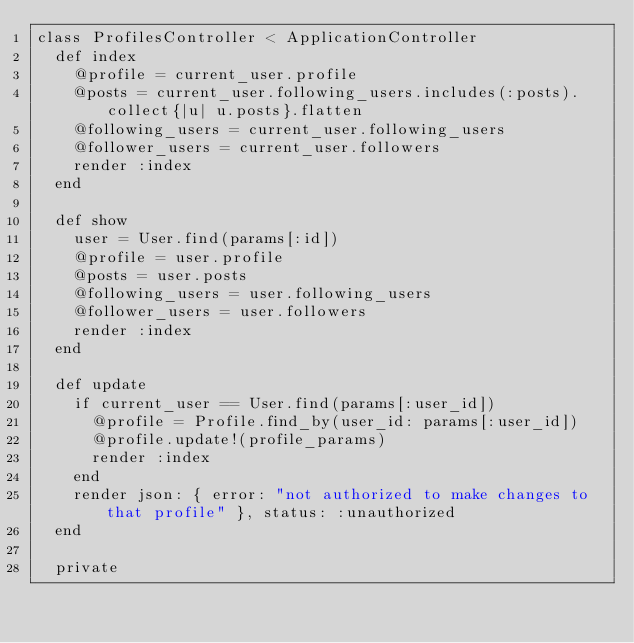<code> <loc_0><loc_0><loc_500><loc_500><_Ruby_>class ProfilesController < ApplicationController
  def index
    @profile = current_user.profile
    @posts = current_user.following_users.includes(:posts).collect{|u| u.posts}.flatten
    @following_users = current_user.following_users
    @follower_users = current_user.followers
    render :index
  end

  def show
    user = User.find(params[:id])
    @profile = user.profile
    @posts = user.posts
    @following_users = user.following_users
    @follower_users = user.followers
    render :index
  end

  def update
    if current_user == User.find(params[:user_id])
      @profile = Profile.find_by(user_id: params[:user_id])
      @profile.update!(profile_params)
      render :index
    end
    render json: { error: "not authorized to make changes to that profile" }, status: :unauthorized
  end

  private
</code> 